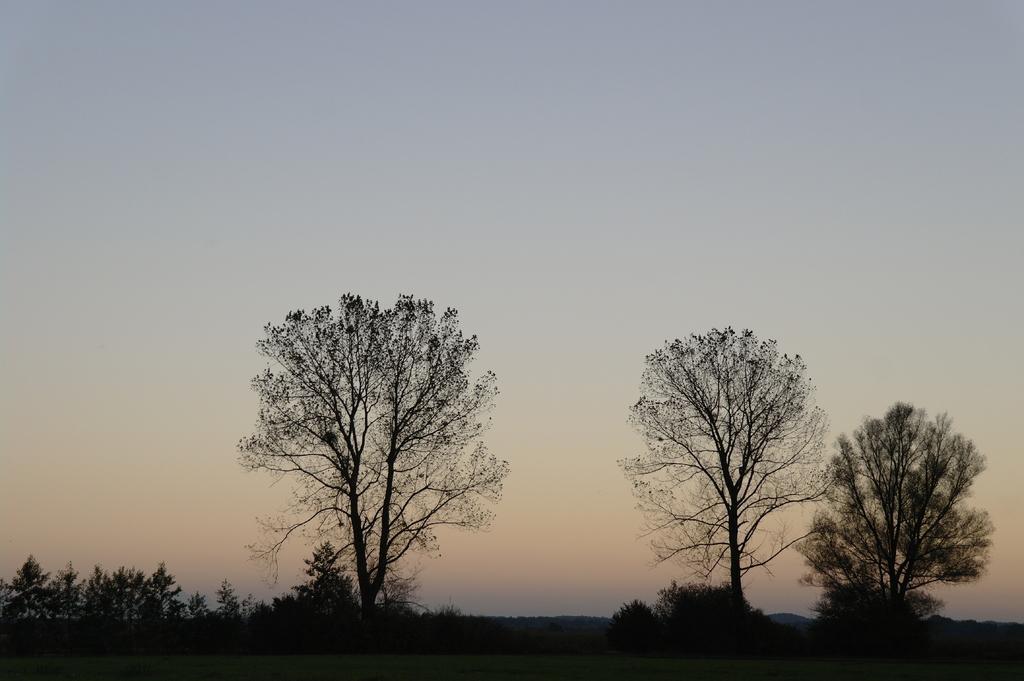In one or two sentences, can you explain what this image depicts? In this image we can see trees and grass on the ground. In the background there are trees and sky. 